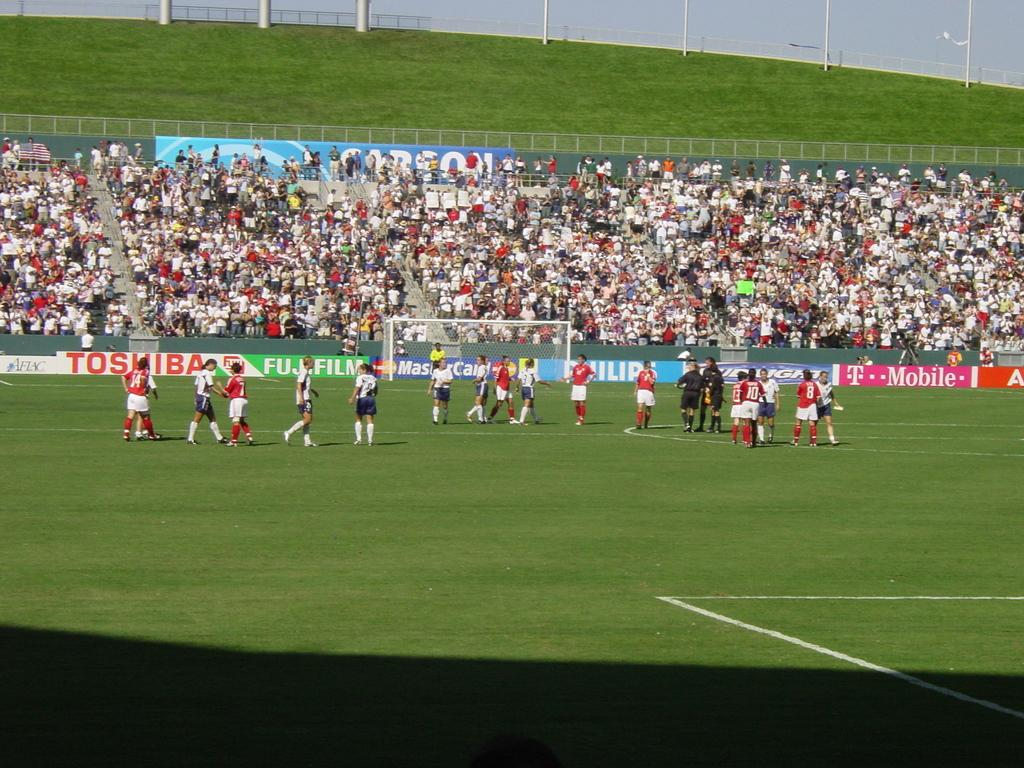What can be seen in the image? There are people standing in the image, along with a goal court, grass, a fence, and poles. Where are the people standing? The people are standing in a ground. What is the main feature in the center of the image? There is a goal court in the center of the image. What type of surface is visible in the image? There is grass in the image. Are there any structures surrounding the area? Yes, there is a fence in the image. What else can be seen in the image? There are poles in the image. Can you see any giants or ghosts in the image? No, there are no giants or ghosts present in the image. What type of muscle is being exercised by the people in the image? The image does not show the people exercising any specific muscle; they are simply standing. 